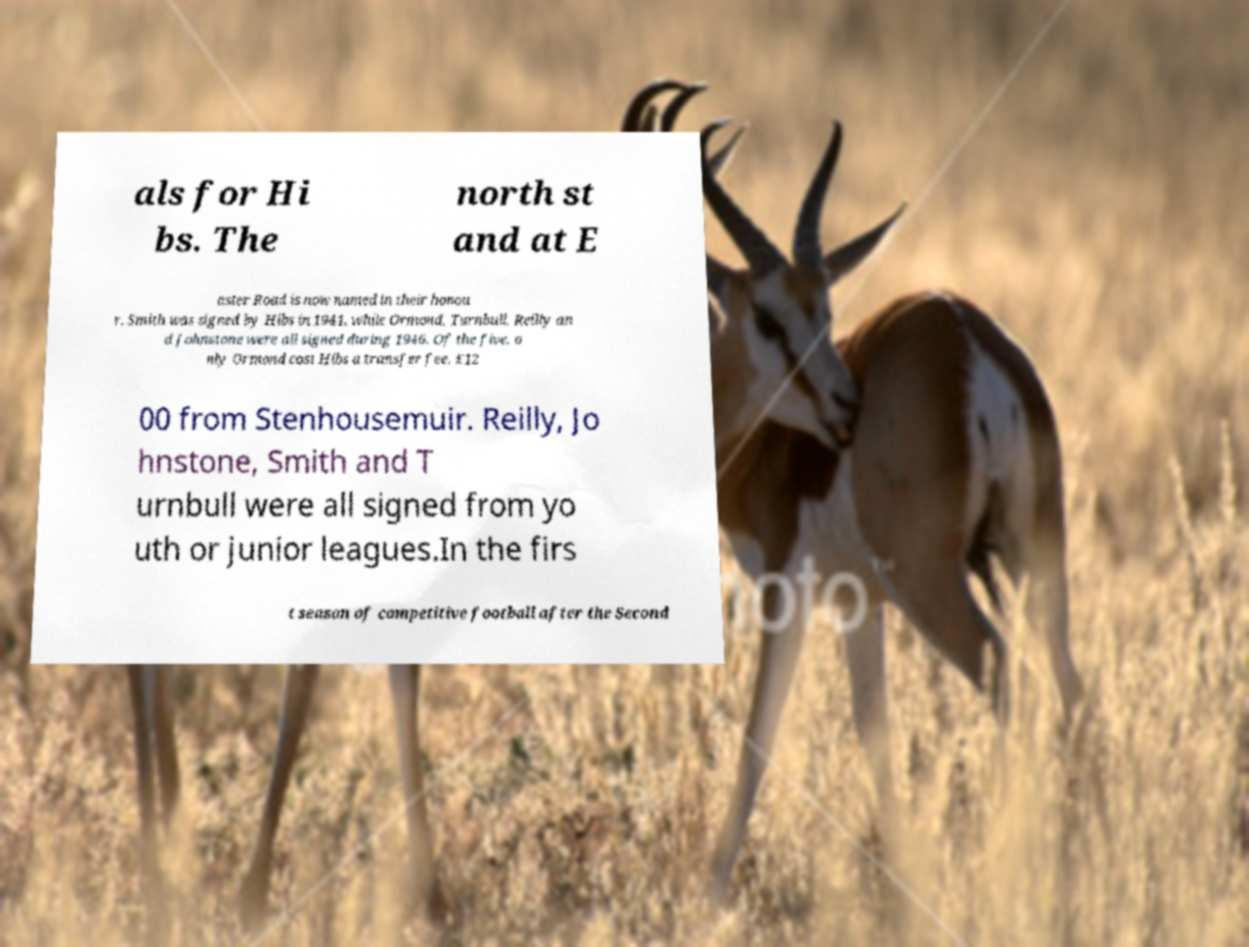What messages or text are displayed in this image? I need them in a readable, typed format. als for Hi bs. The north st and at E aster Road is now named in their honou r. Smith was signed by Hibs in 1941, while Ormond, Turnbull, Reilly an d Johnstone were all signed during 1946. Of the five, o nly Ormond cost Hibs a transfer fee, £12 00 from Stenhousemuir. Reilly, Jo hnstone, Smith and T urnbull were all signed from yo uth or junior leagues.In the firs t season of competitive football after the Second 